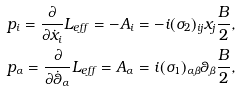<formula> <loc_0><loc_0><loc_500><loc_500>& p _ { i } = \frac { \partial } { \partial \dot { x } _ { i } } L _ { e f f } = - A _ { i } = - i ( \sigma _ { 2 } ) _ { i j } x _ { j } \frac { B } { 2 } , \\ & p _ { \alpha } = \frac { \partial } { \partial \dot { \theta } _ { \alpha } } L _ { e f f } = A _ { \alpha } = i ( \sigma _ { 1 } ) _ { \alpha \beta } \theta _ { \beta } \frac { B } { 2 } ,</formula> 